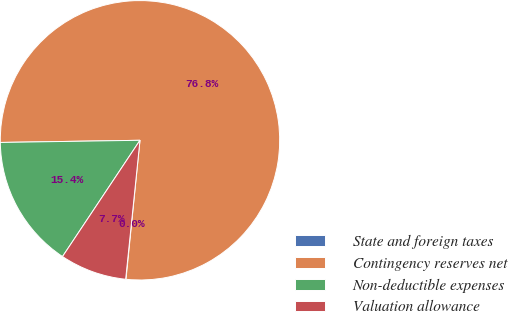Convert chart to OTSL. <chart><loc_0><loc_0><loc_500><loc_500><pie_chart><fcel>State and foreign taxes<fcel>Contingency reserves net<fcel>Non-deductible expenses<fcel>Valuation allowance<nl><fcel>0.04%<fcel>76.85%<fcel>15.4%<fcel>7.72%<nl></chart> 